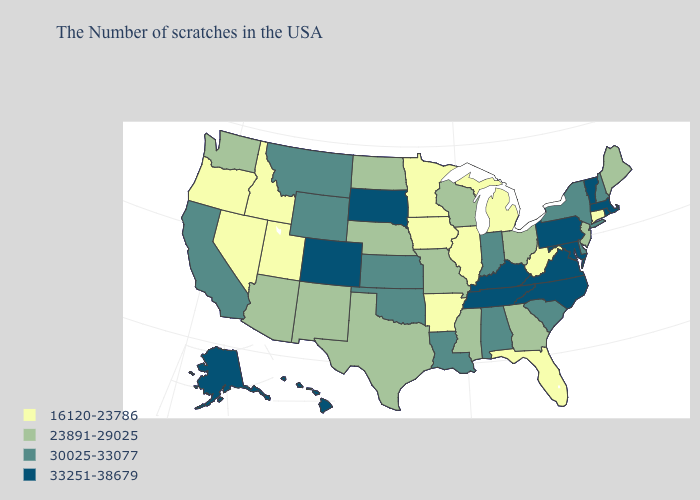What is the value of Washington?
Concise answer only. 23891-29025. Does the first symbol in the legend represent the smallest category?
Give a very brief answer. Yes. What is the value of North Dakota?
Quick response, please. 23891-29025. Does Montana have the lowest value in the West?
Write a very short answer. No. Name the states that have a value in the range 23891-29025?
Quick response, please. Maine, New Jersey, Ohio, Georgia, Wisconsin, Mississippi, Missouri, Nebraska, Texas, North Dakota, New Mexico, Arizona, Washington. Does Minnesota have the lowest value in the USA?
Answer briefly. Yes. Does the first symbol in the legend represent the smallest category?
Short answer required. Yes. Name the states that have a value in the range 33251-38679?
Concise answer only. Massachusetts, Rhode Island, Vermont, Maryland, Pennsylvania, Virginia, North Carolina, Kentucky, Tennessee, South Dakota, Colorado, Alaska, Hawaii. Does New Hampshire have a lower value than Wisconsin?
Short answer required. No. What is the highest value in states that border Vermont?
Keep it brief. 33251-38679. Among the states that border South Dakota , does Minnesota have the lowest value?
Answer briefly. Yes. Does Oregon have the lowest value in the USA?
Be succinct. Yes. What is the highest value in the MidWest ?
Give a very brief answer. 33251-38679. What is the value of Wyoming?
Concise answer only. 30025-33077. What is the lowest value in the USA?
Quick response, please. 16120-23786. 